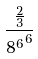<formula> <loc_0><loc_0><loc_500><loc_500>\frac { \frac { 2 } { 3 } } { { 8 ^ { 6 } } ^ { 6 } }</formula> 